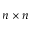<formula> <loc_0><loc_0><loc_500><loc_500>n \times n</formula> 